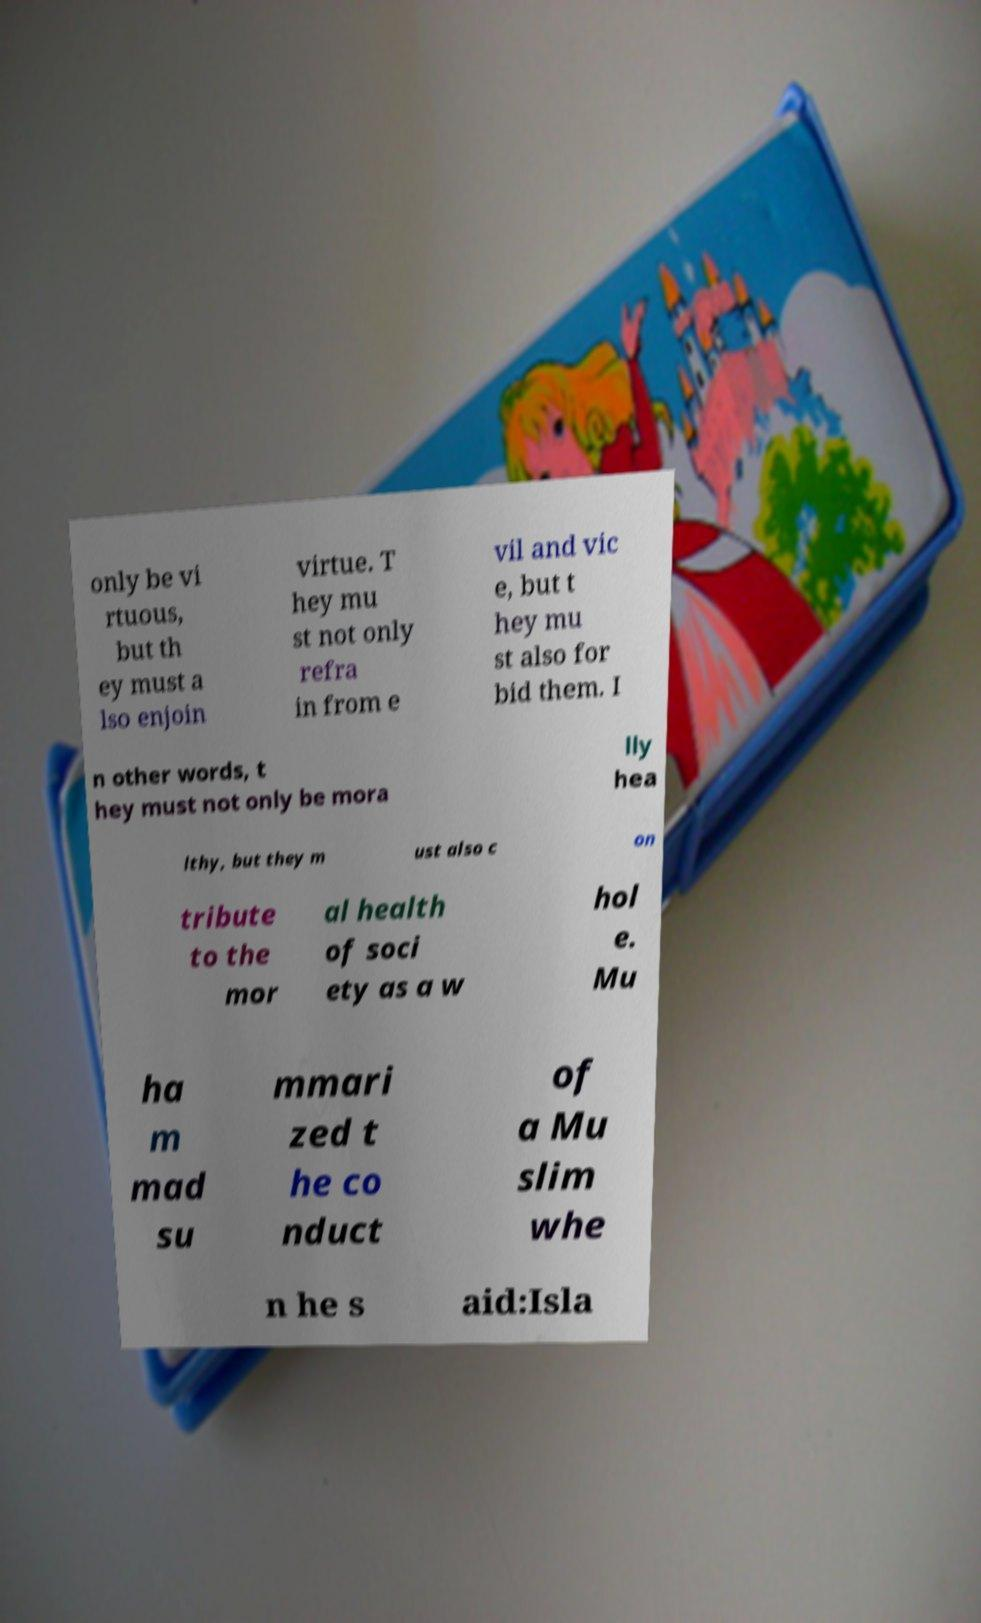Please identify and transcribe the text found in this image. only be vi rtuous, but th ey must a lso enjoin virtue. T hey mu st not only refra in from e vil and vic e, but t hey mu st also for bid them. I n other words, t hey must not only be mora lly hea lthy, but they m ust also c on tribute to the mor al health of soci ety as a w hol e. Mu ha m mad su mmari zed t he co nduct of a Mu slim whe n he s aid:Isla 